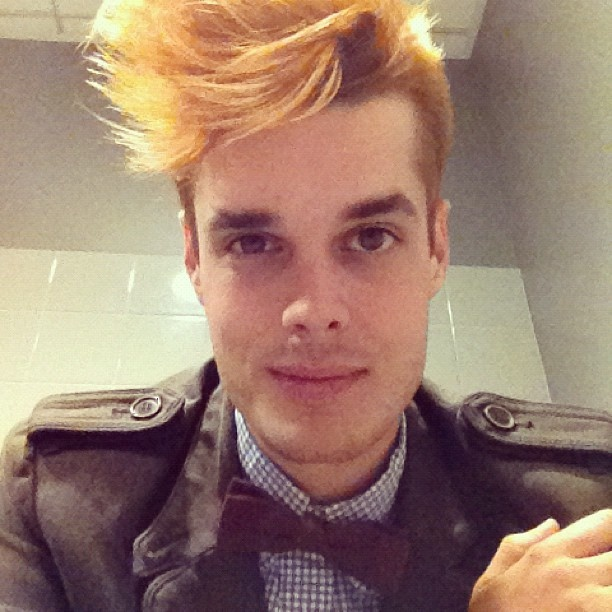Describe the objects in this image and their specific colors. I can see people in tan, brown, black, and purple tones and tie in tan and purple tones in this image. 